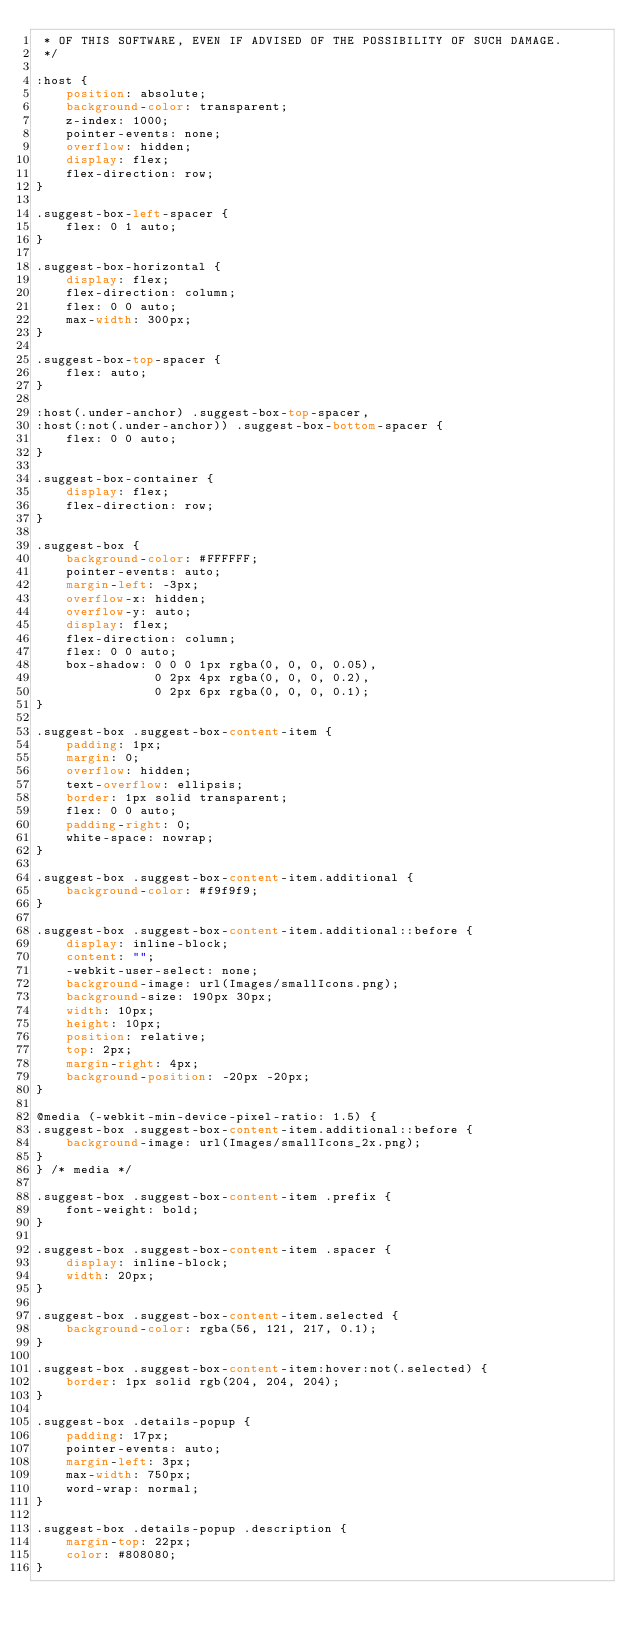<code> <loc_0><loc_0><loc_500><loc_500><_CSS_> * OF THIS SOFTWARE, EVEN IF ADVISED OF THE POSSIBILITY OF SUCH DAMAGE.
 */

:host {
    position: absolute;
    background-color: transparent;
    z-index: 1000;
    pointer-events: none;
    overflow: hidden;
    display: flex;
    flex-direction: row;
}

.suggest-box-left-spacer {
    flex: 0 1 auto;
}

.suggest-box-horizontal {
    display: flex;
    flex-direction: column;
    flex: 0 0 auto;
    max-width: 300px;
}

.suggest-box-top-spacer {
    flex: auto;
}

:host(.under-anchor) .suggest-box-top-spacer,
:host(:not(.under-anchor)) .suggest-box-bottom-spacer {
    flex: 0 0 auto;
}

.suggest-box-container {
    display: flex;
    flex-direction: row;
}

.suggest-box {
    background-color: #FFFFFF;
    pointer-events: auto;
    margin-left: -3px;
    overflow-x: hidden;
    overflow-y: auto;
    display: flex;
    flex-direction: column;
    flex: 0 0 auto;
    box-shadow: 0 0 0 1px rgba(0, 0, 0, 0.05),
                0 2px 4px rgba(0, 0, 0, 0.2),
                0 2px 6px rgba(0, 0, 0, 0.1);
}

.suggest-box .suggest-box-content-item {
    padding: 1px;
    margin: 0;
    overflow: hidden;
    text-overflow: ellipsis;
    border: 1px solid transparent;
    flex: 0 0 auto;
    padding-right: 0;
    white-space: nowrap;
}

.suggest-box .suggest-box-content-item.additional {
    background-color: #f9f9f9;
}

.suggest-box .suggest-box-content-item.additional::before {
    display: inline-block;
    content: "";
    -webkit-user-select: none;
    background-image: url(Images/smallIcons.png);
    background-size: 190px 30px;
    width: 10px;
    height: 10px;
    position: relative;
    top: 2px;
    margin-right: 4px;
    background-position: -20px -20px;
}

@media (-webkit-min-device-pixel-ratio: 1.5) {
.suggest-box .suggest-box-content-item.additional::before {
    background-image: url(Images/smallIcons_2x.png);
}
} /* media */

.suggest-box .suggest-box-content-item .prefix {
    font-weight: bold;
}

.suggest-box .suggest-box-content-item .spacer {
    display: inline-block;
    width: 20px;
}

.suggest-box .suggest-box-content-item.selected {
    background-color: rgba(56, 121, 217, 0.1);
}

.suggest-box .suggest-box-content-item:hover:not(.selected) {
    border: 1px solid rgb(204, 204, 204);
}

.suggest-box .details-popup {
    padding: 17px;
    pointer-events: auto;
    margin-left: 3px;
    max-width: 750px;
    word-wrap: normal;
}

.suggest-box .details-popup .description {
    margin-top: 22px;
    color: #808080;
}
</code> 